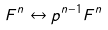Convert formula to latex. <formula><loc_0><loc_0><loc_500><loc_500>F ^ { n } \leftrightarrow p ^ { n - 1 } F ^ { n }</formula> 